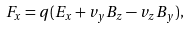<formula> <loc_0><loc_0><loc_500><loc_500>F _ { x } = q ( E _ { x } + v _ { y } B _ { z } - v _ { z } B _ { y } ) ,</formula> 